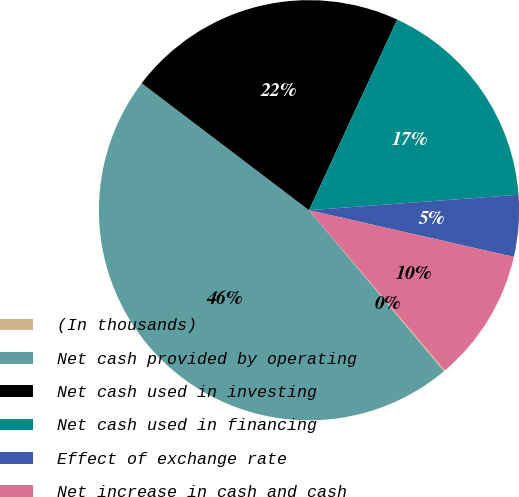Convert chart to OTSL. <chart><loc_0><loc_0><loc_500><loc_500><pie_chart><fcel>(In thousands)<fcel>Net cash provided by operating<fcel>Net cash used in investing<fcel>Net cash used in financing<fcel>Effect of exchange rate<fcel>Net increase in cash and cash<nl><fcel>0.11%<fcel>46.42%<fcel>21.56%<fcel>16.93%<fcel>4.74%<fcel>10.23%<nl></chart> 